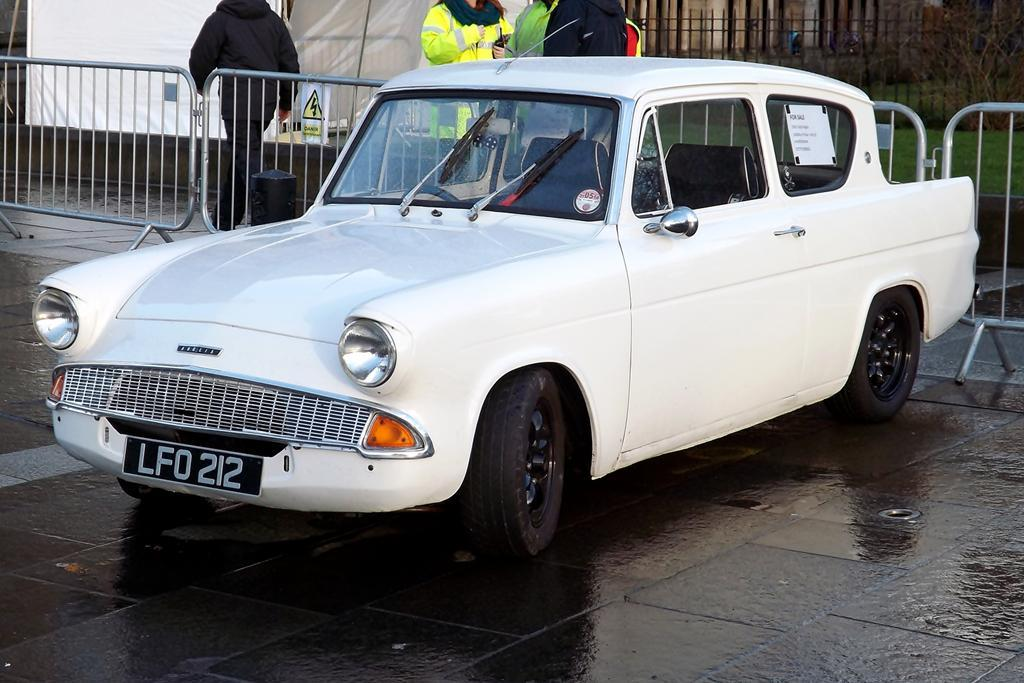What type of vehicle is in the image? There is a white car in the image. Where is the car located? The car is on the road. What is behind the car? There is a fence behind the car. What is happening around the car? There are people walking behind the car. What type of clouds can be seen in the picture? There is no picture mentioned in the facts, and no clouds are visible in the image. 